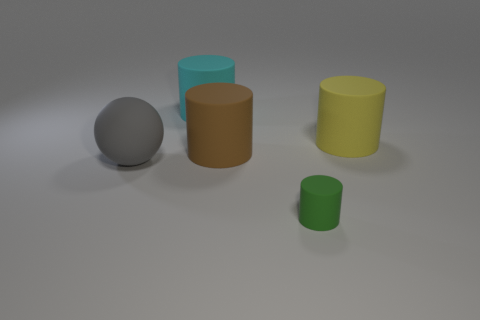Subtract all yellow rubber cylinders. How many cylinders are left? 3 Subtract 1 balls. How many balls are left? 0 Add 4 green rubber cubes. How many objects exist? 9 Subtract all yellow cylinders. How many cylinders are left? 3 Subtract 0 red cylinders. How many objects are left? 5 Subtract all cylinders. How many objects are left? 1 Subtract all purple cylinders. Subtract all red cubes. How many cylinders are left? 4 Subtract all red balls. How many gray cylinders are left? 0 Subtract all blue metallic cubes. Subtract all tiny matte things. How many objects are left? 4 Add 5 big brown cylinders. How many big brown cylinders are left? 6 